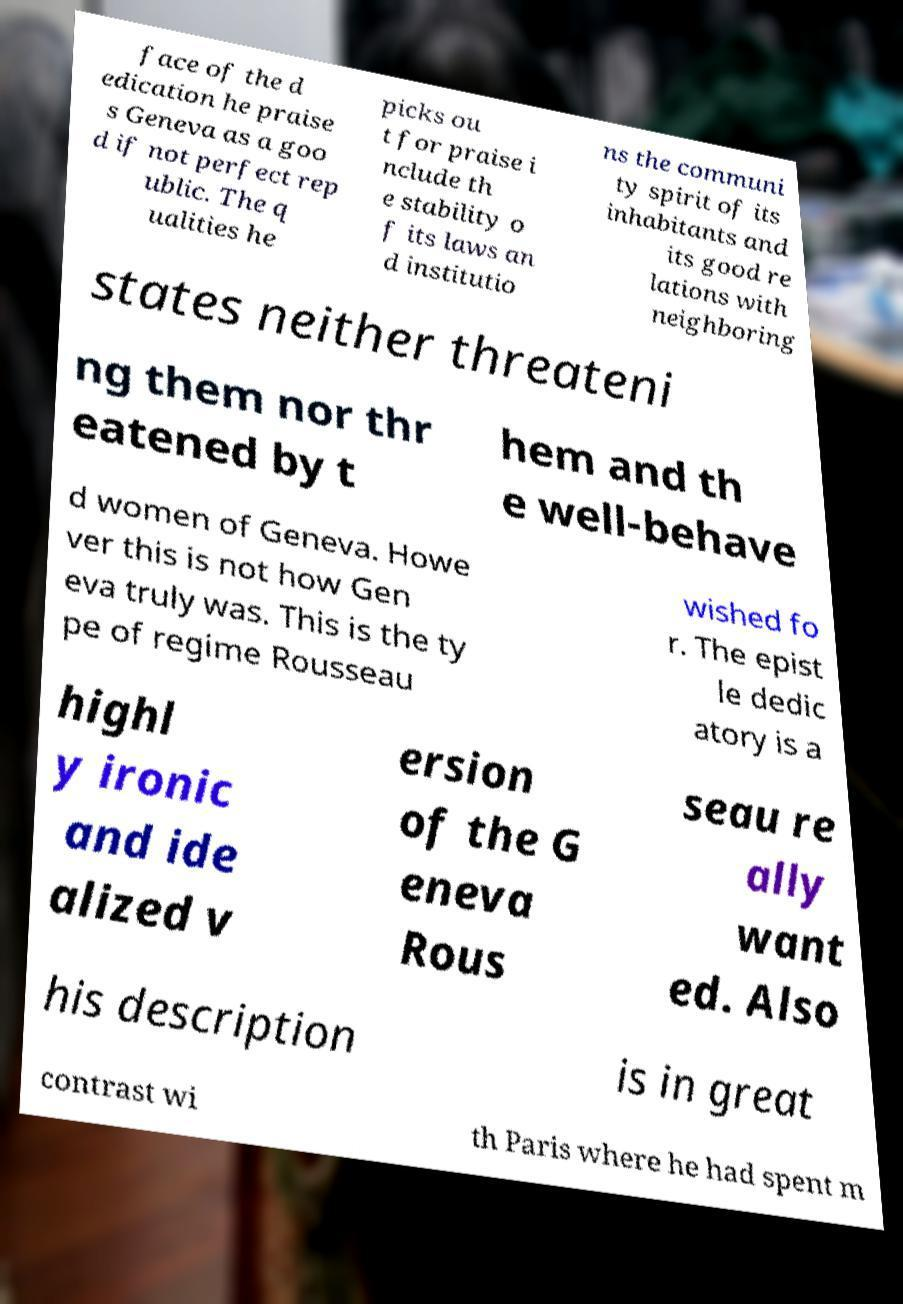I need the written content from this picture converted into text. Can you do that? face of the d edication he praise s Geneva as a goo d if not perfect rep ublic. The q ualities he picks ou t for praise i nclude th e stability o f its laws an d institutio ns the communi ty spirit of its inhabitants and its good re lations with neighboring states neither threateni ng them nor thr eatened by t hem and th e well-behave d women of Geneva. Howe ver this is not how Gen eva truly was. This is the ty pe of regime Rousseau wished fo r. The epist le dedic atory is a highl y ironic and ide alized v ersion of the G eneva Rous seau re ally want ed. Also his description is in great contrast wi th Paris where he had spent m 